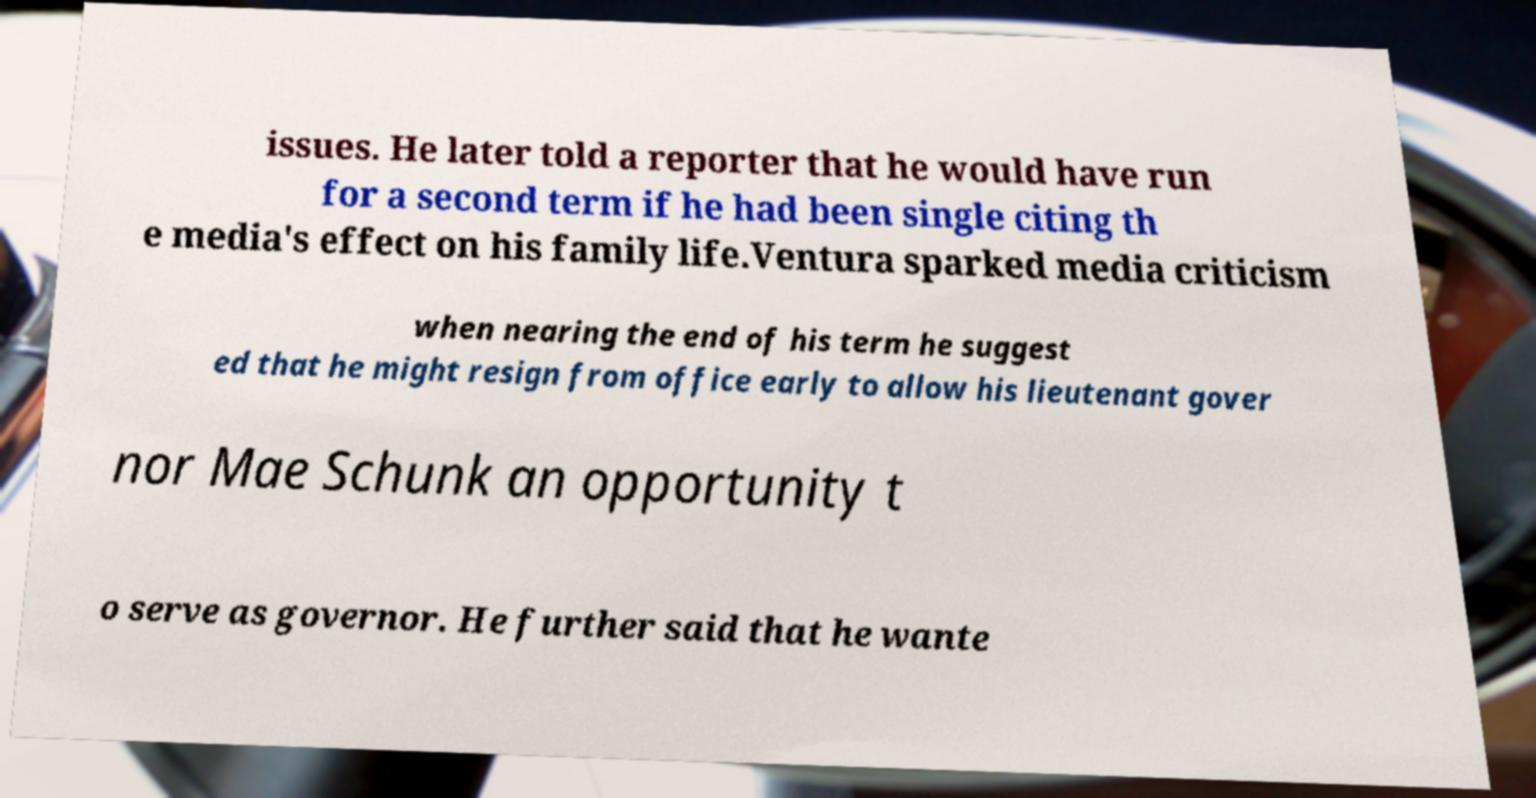Could you extract and type out the text from this image? issues. He later told a reporter that he would have run for a second term if he had been single citing th e media's effect on his family life.Ventura sparked media criticism when nearing the end of his term he suggest ed that he might resign from office early to allow his lieutenant gover nor Mae Schunk an opportunity t o serve as governor. He further said that he wante 